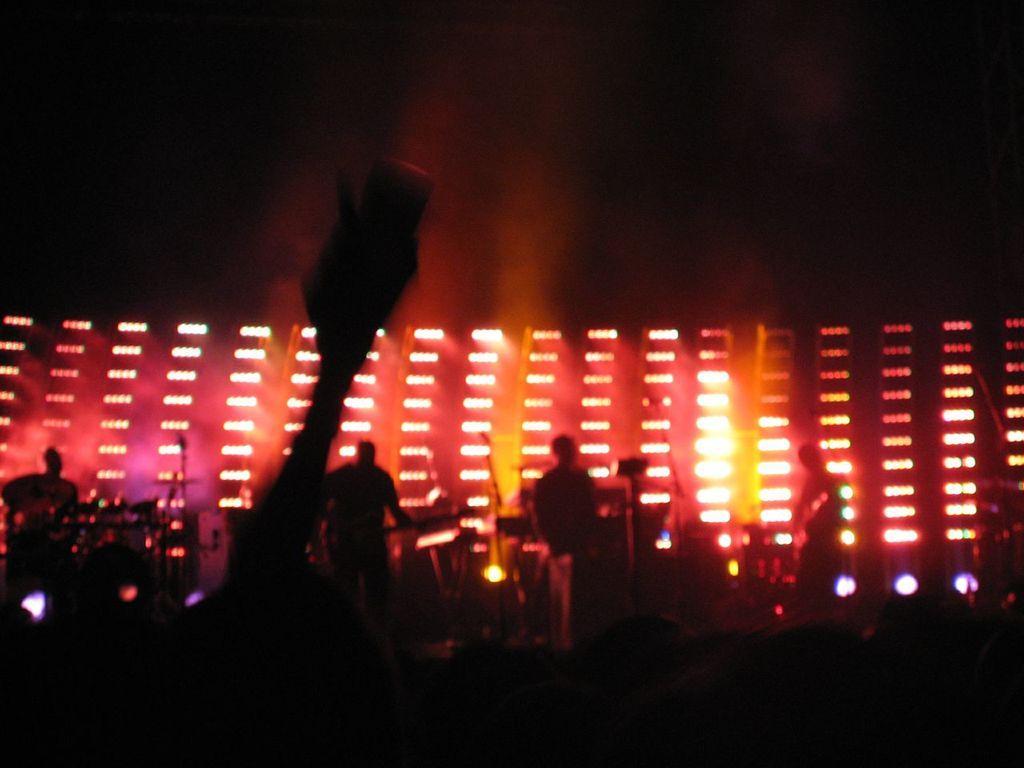Please provide a concise description of this image. In this picture I can see some people are standing on the stage. I can also see stage lights and other objects on the stage. 